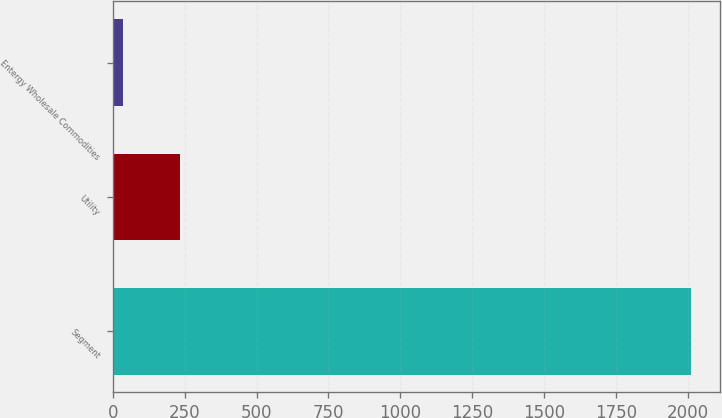Convert chart. <chart><loc_0><loc_0><loc_500><loc_500><bar_chart><fcel>Segment<fcel>Utility<fcel>Entergy Wholesale Commodities<nl><fcel>2011<fcel>233.5<fcel>36<nl></chart> 